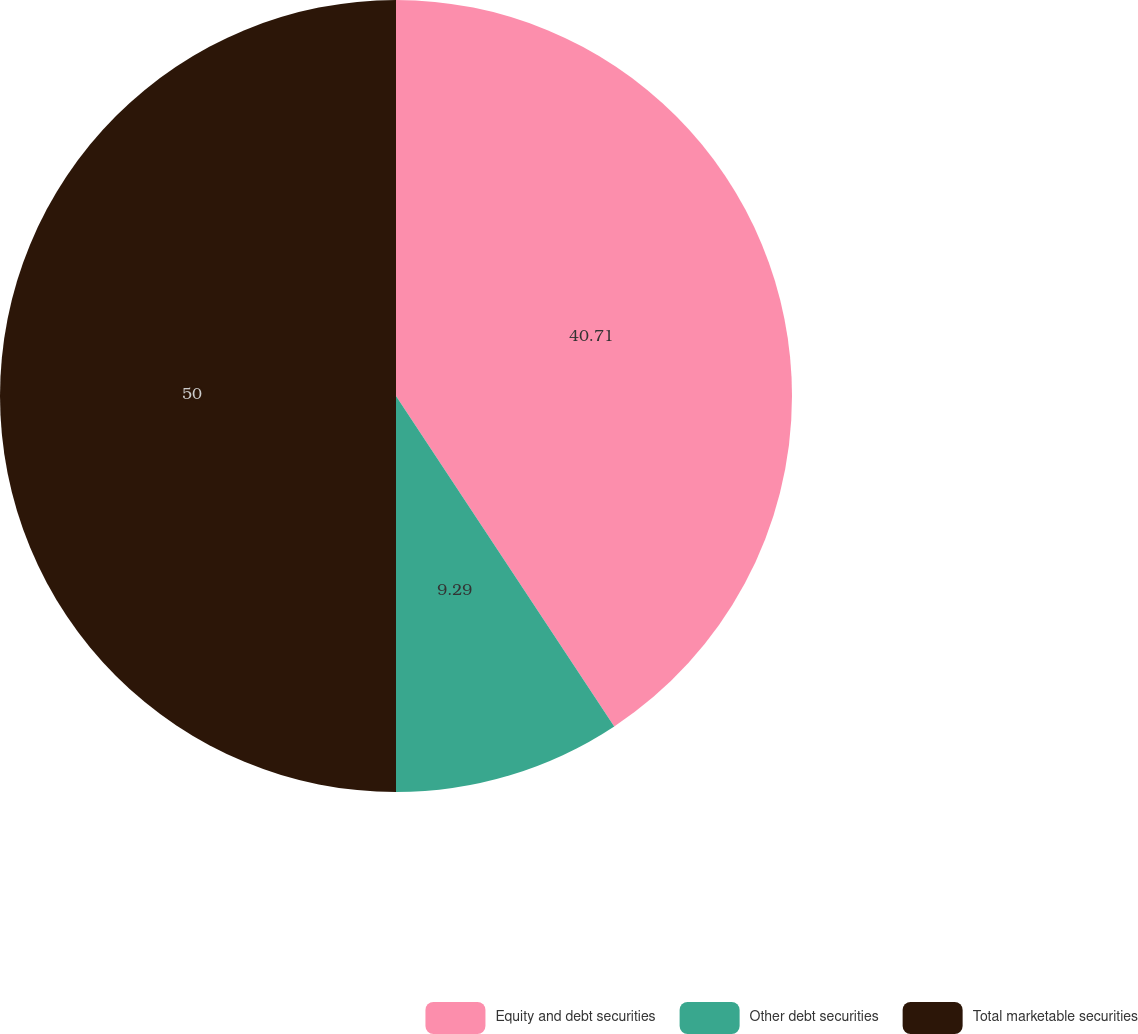<chart> <loc_0><loc_0><loc_500><loc_500><pie_chart><fcel>Equity and debt securities<fcel>Other debt securities<fcel>Total marketable securities<nl><fcel>40.71%<fcel>9.29%<fcel>50.0%<nl></chart> 